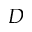Convert formula to latex. <formula><loc_0><loc_0><loc_500><loc_500>D</formula> 